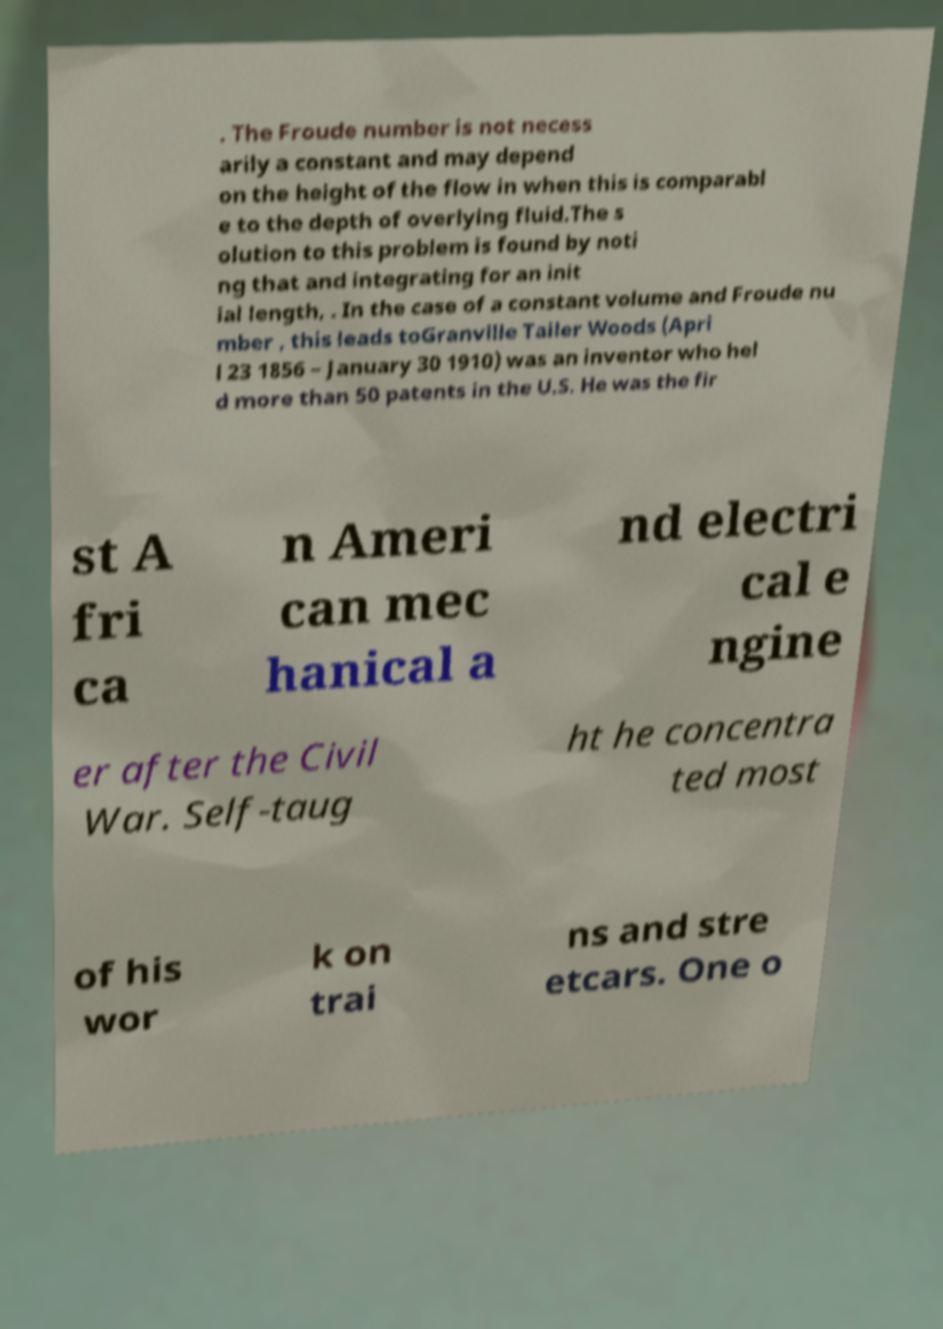Could you assist in decoding the text presented in this image and type it out clearly? . The Froude number is not necess arily a constant and may depend on the height of the flow in when this is comparabl e to the depth of overlying fluid.The s olution to this problem is found by noti ng that and integrating for an init ial length, . In the case of a constant volume and Froude nu mber , this leads toGranville Tailer Woods (Apri l 23 1856 – January 30 1910) was an inventor who hel d more than 50 patents in the U.S. He was the fir st A fri ca n Ameri can mec hanical a nd electri cal e ngine er after the Civil War. Self-taug ht he concentra ted most of his wor k on trai ns and stre etcars. One o 